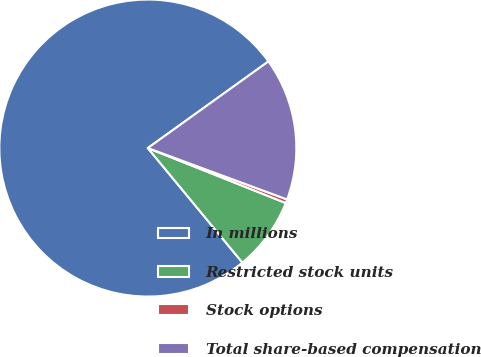Convert chart to OTSL. <chart><loc_0><loc_0><loc_500><loc_500><pie_chart><fcel>In millions<fcel>Restricted stock units<fcel>Stock options<fcel>Total share-based compensation<nl><fcel>76.07%<fcel>7.98%<fcel>0.41%<fcel>15.54%<nl></chart> 